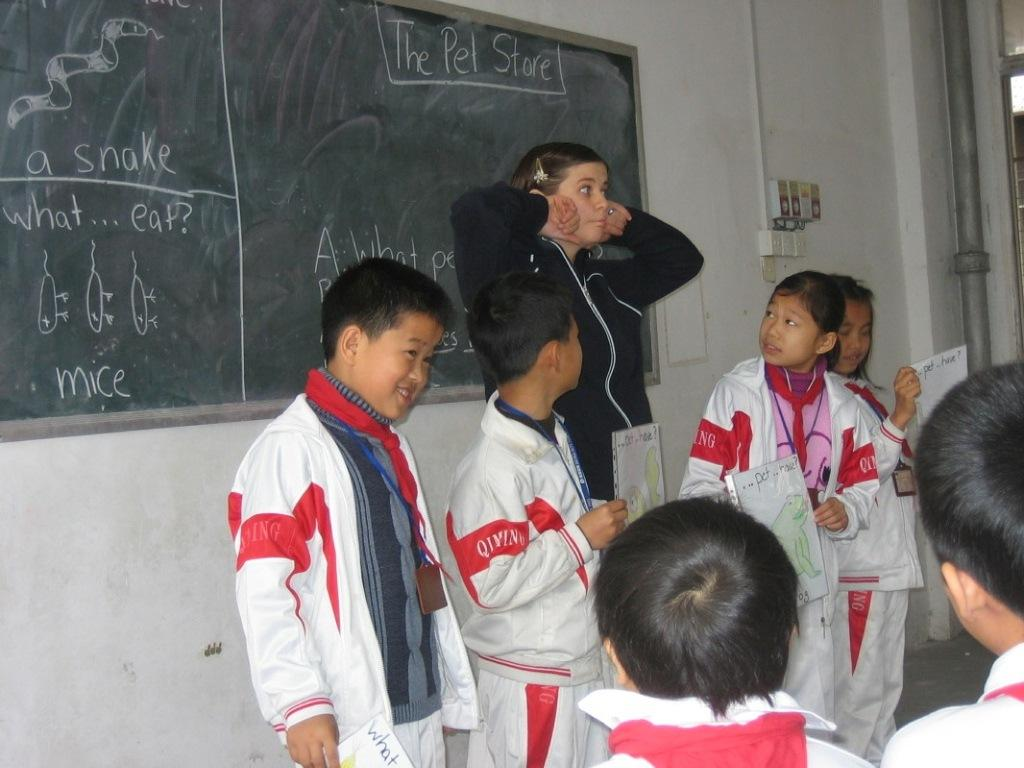<image>
Create a compact narrative representing the image presented. Several children look at their teacher who is pulling a face in front of a blackboard with the The Pet Store written on it 